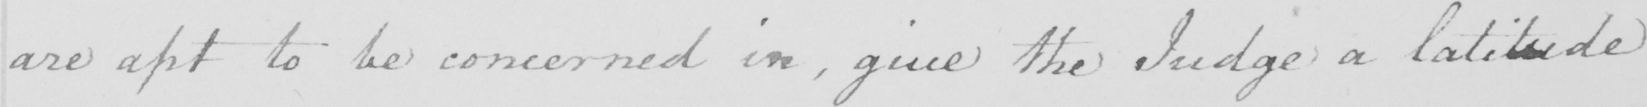Please transcribe the handwritten text in this image. are apt to be concerned in , give the Judge a latitude 